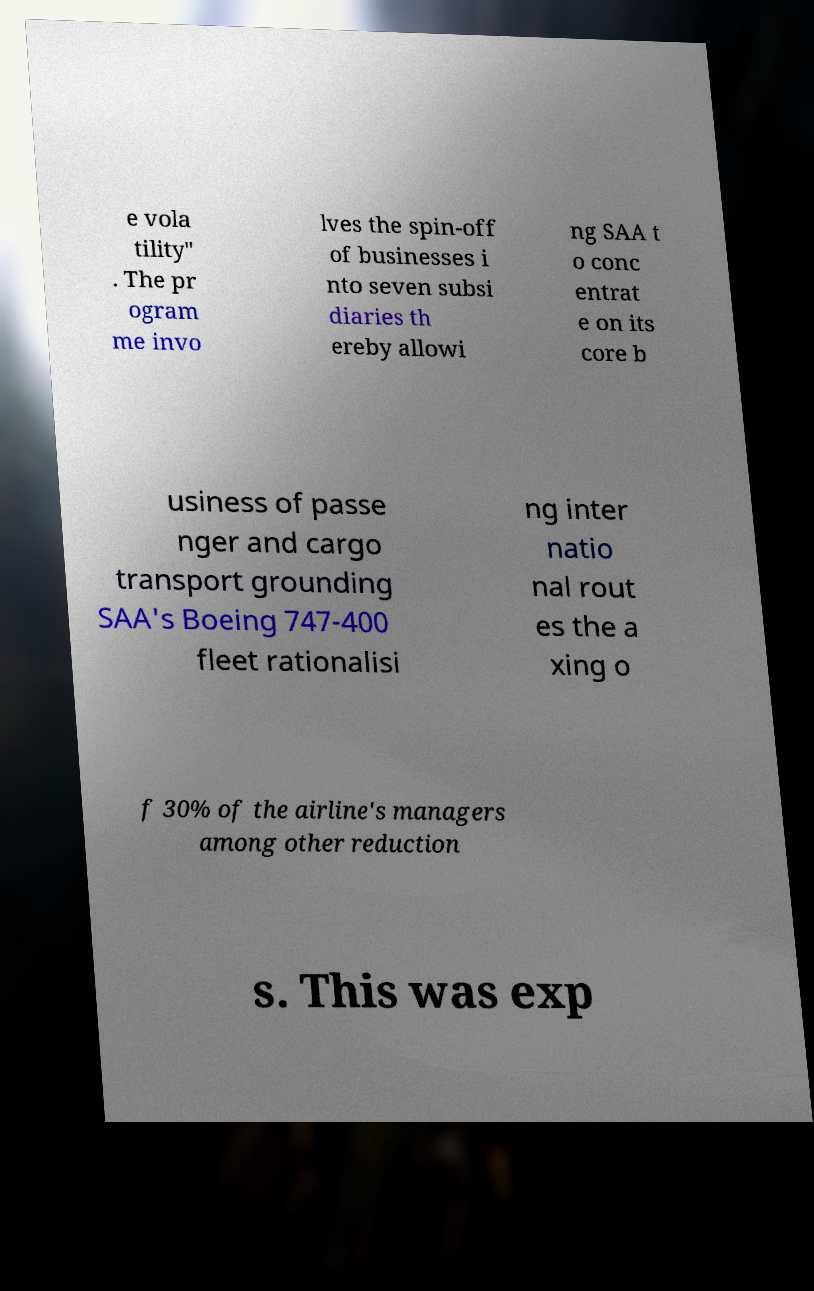Can you read and provide the text displayed in the image?This photo seems to have some interesting text. Can you extract and type it out for me? e vola tility" . The pr ogram me invo lves the spin-off of businesses i nto seven subsi diaries th ereby allowi ng SAA t o conc entrat e on its core b usiness of passe nger and cargo transport grounding SAA's Boeing 747-400 fleet rationalisi ng inter natio nal rout es the a xing o f 30% of the airline's managers among other reduction s. This was exp 